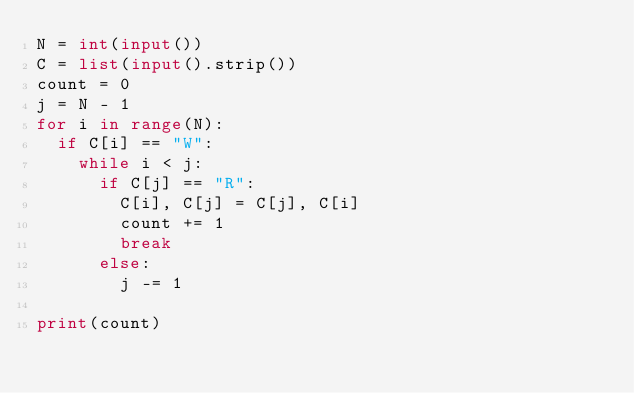Convert code to text. <code><loc_0><loc_0><loc_500><loc_500><_Python_>N = int(input())
C = list(input().strip())
count = 0
j = N - 1
for i in range(N):
  if C[i] == "W":
    while i < j:
      if C[j] == "R":
        C[i], C[j] = C[j], C[i]
        count += 1
        break
      else:
        j -= 1

print(count)</code> 